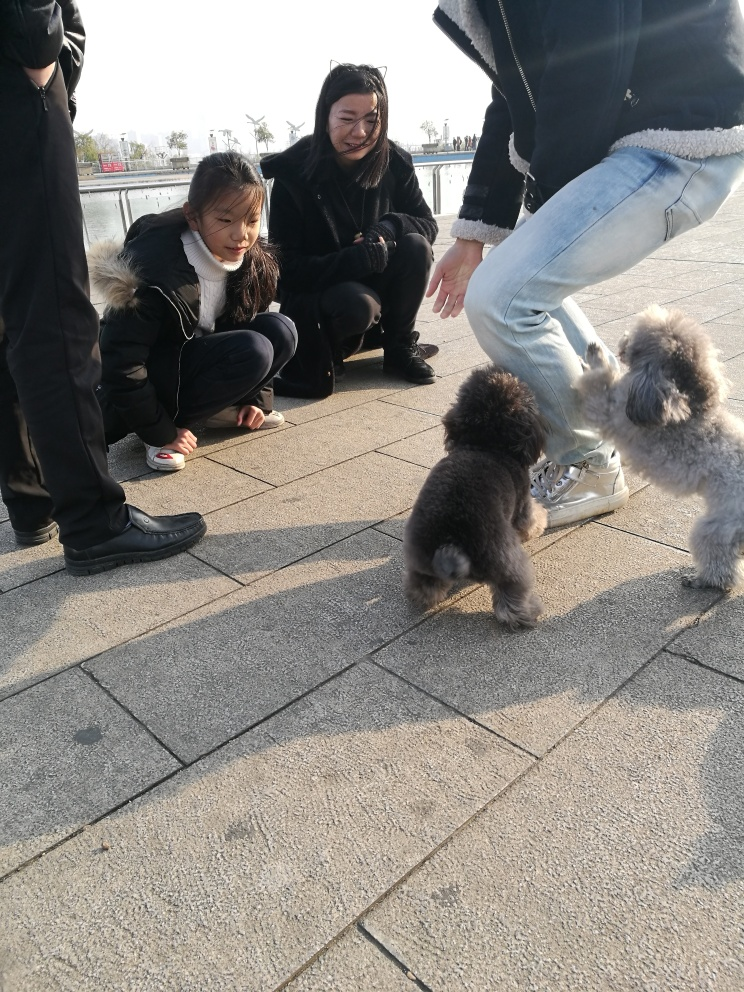Are the colors in the image dull?
 No 